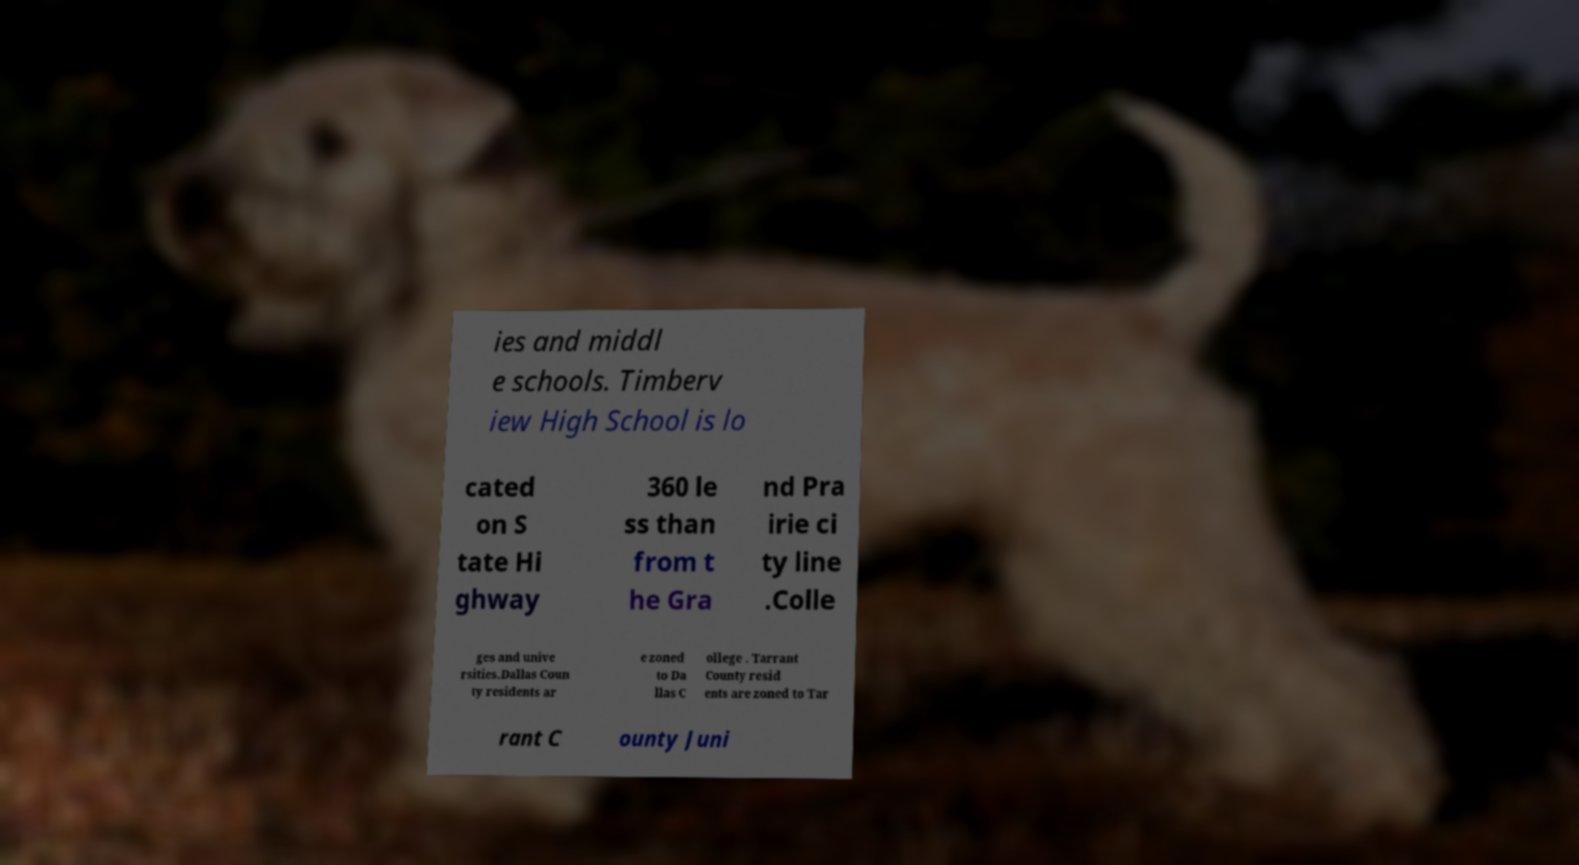For documentation purposes, I need the text within this image transcribed. Could you provide that? ies and middl e schools. Timberv iew High School is lo cated on S tate Hi ghway 360 le ss than from t he Gra nd Pra irie ci ty line .Colle ges and unive rsities.Dallas Coun ty residents ar e zoned to Da llas C ollege . Tarrant County resid ents are zoned to Tar rant C ounty Juni 